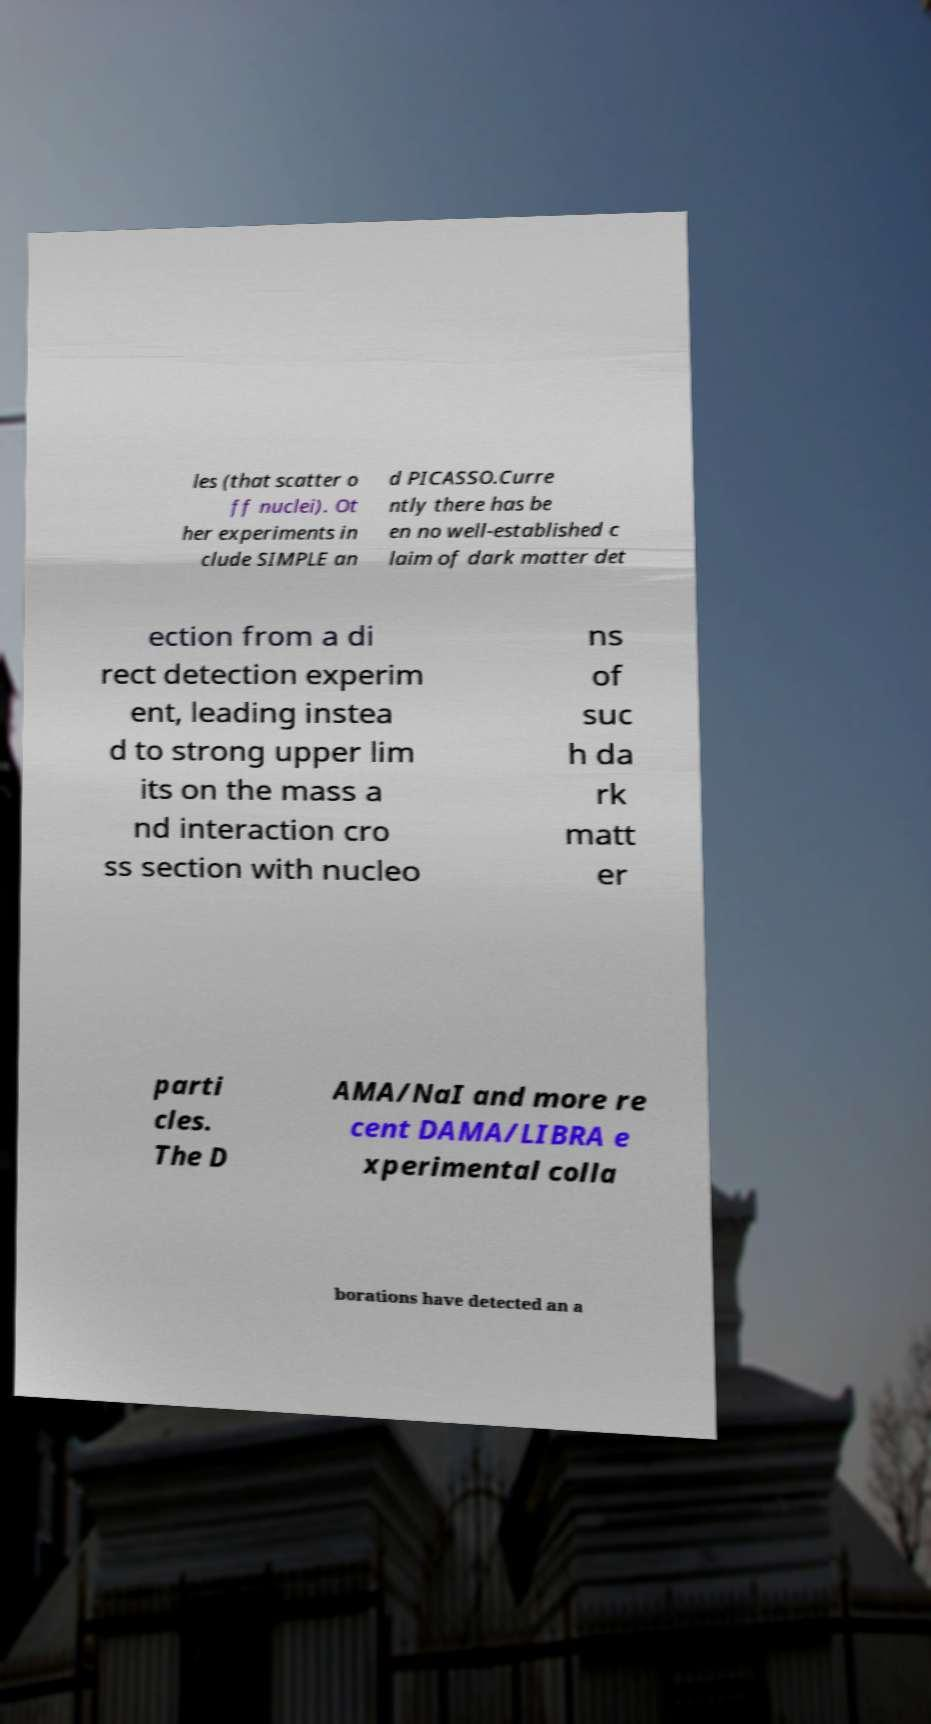What messages or text are displayed in this image? I need them in a readable, typed format. les (that scatter o ff nuclei). Ot her experiments in clude SIMPLE an d PICASSO.Curre ntly there has be en no well-established c laim of dark matter det ection from a di rect detection experim ent, leading instea d to strong upper lim its on the mass a nd interaction cro ss section with nucleo ns of suc h da rk matt er parti cles. The D AMA/NaI and more re cent DAMA/LIBRA e xperimental colla borations have detected an a 